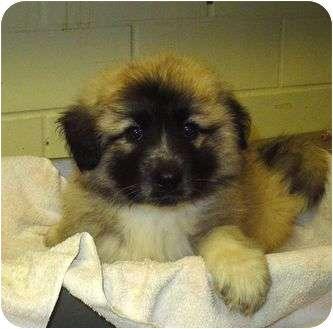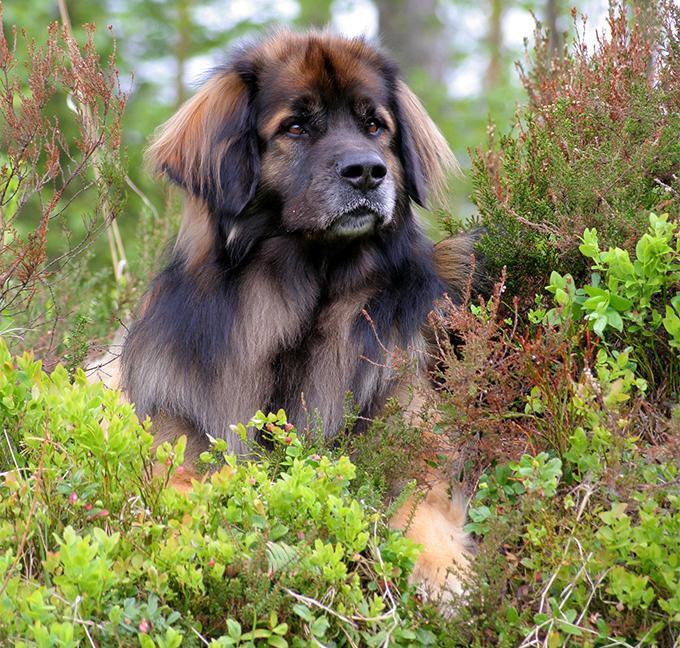The first image is the image on the left, the second image is the image on the right. For the images displayed, is the sentence "One image shows at least one dog on snowy ground." factually correct? Answer yes or no. No. The first image is the image on the left, the second image is the image on the right. For the images shown, is this caption "One of the photos shows one or more dogs outside in the snow." true? Answer yes or no. No. 